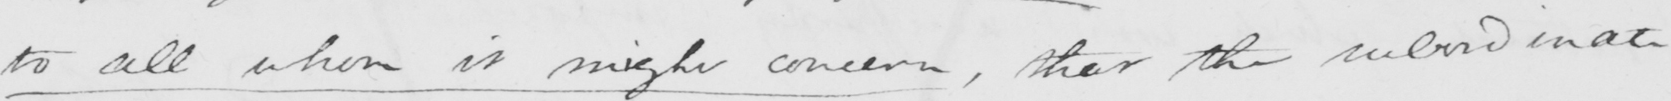Transcribe the text shown in this historical manuscript line. to all whom it might concern , that the subordinate 